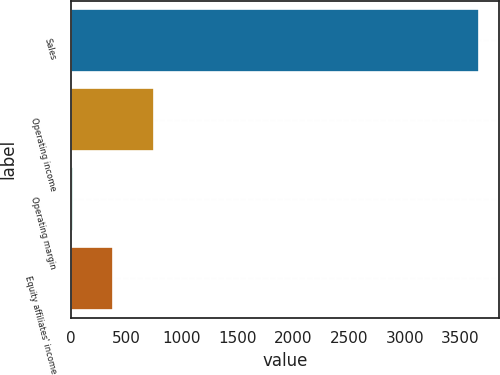Convert chart to OTSL. <chart><loc_0><loc_0><loc_500><loc_500><bar_chart><fcel>Sales<fcel>Operating income<fcel>Operating margin<fcel>Equity affiliates' income<nl><fcel>3664.9<fcel>747.62<fcel>18.3<fcel>382.96<nl></chart> 